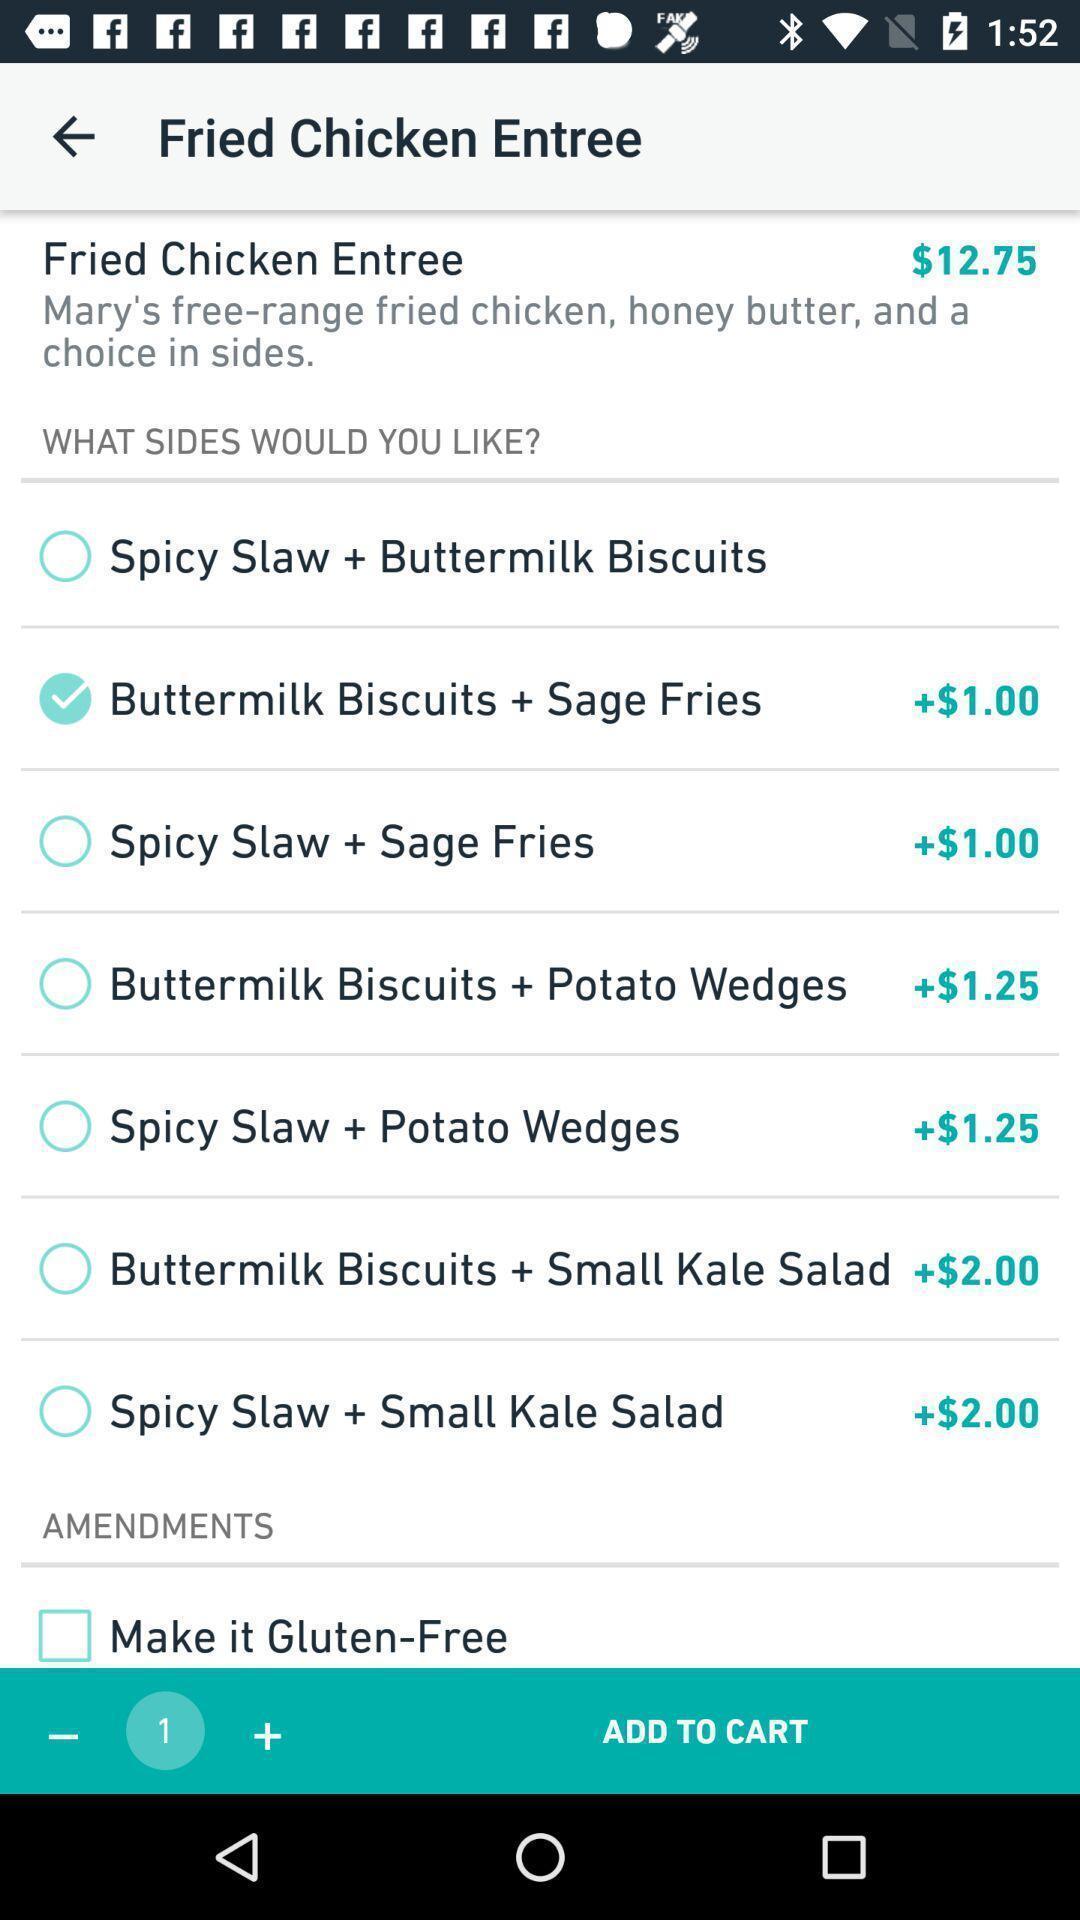Provide a description of this screenshot. Page shows to add food in the cart for ordering. 